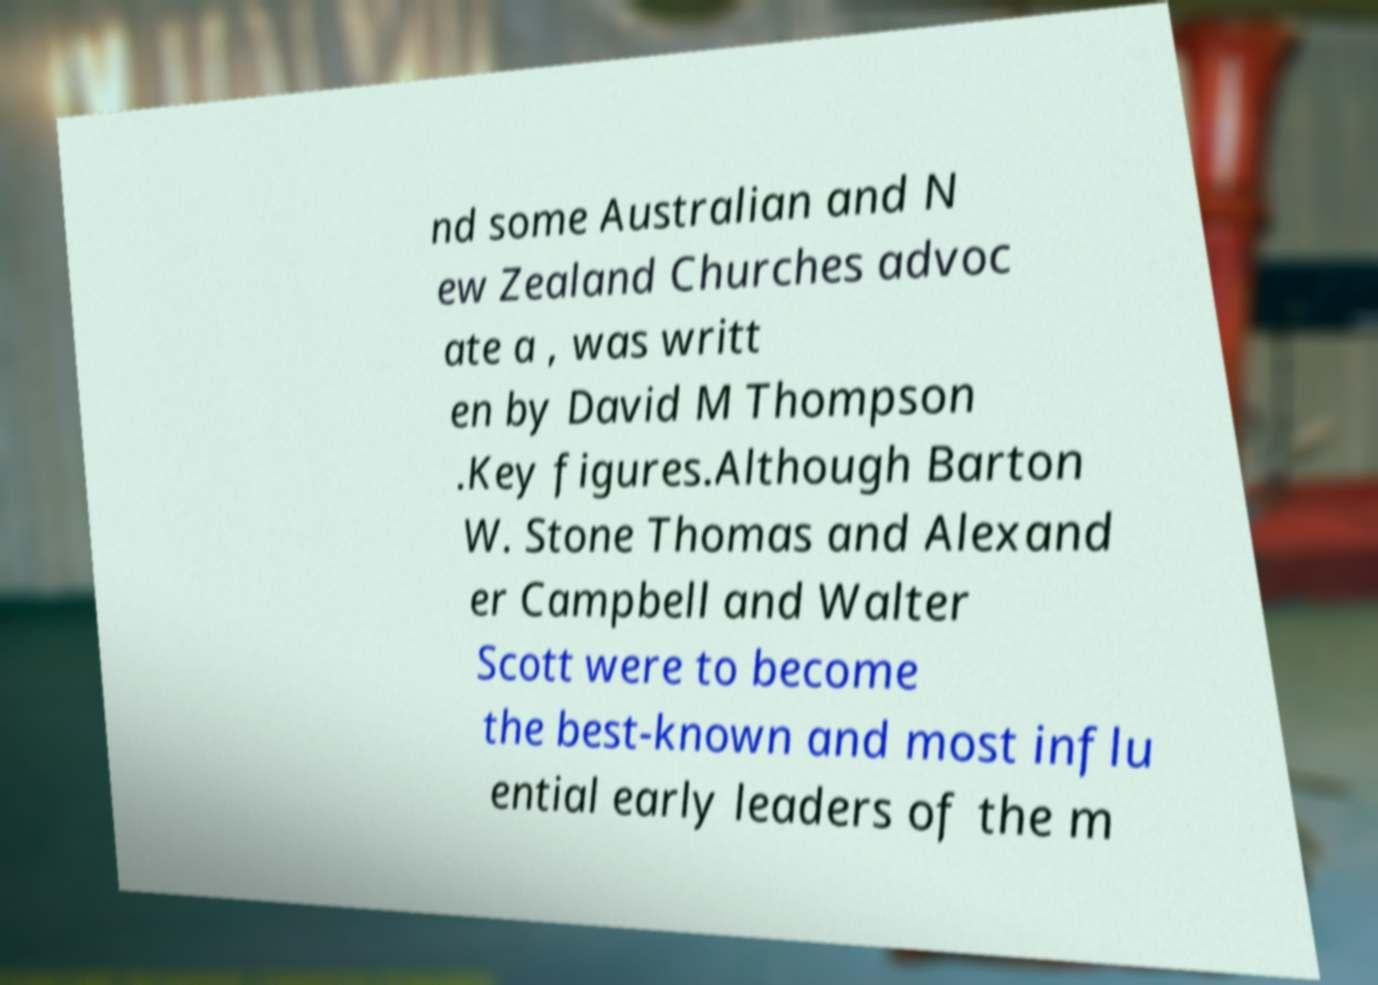Could you extract and type out the text from this image? nd some Australian and N ew Zealand Churches advoc ate a , was writt en by David M Thompson .Key figures.Although Barton W. Stone Thomas and Alexand er Campbell and Walter Scott were to become the best-known and most influ ential early leaders of the m 